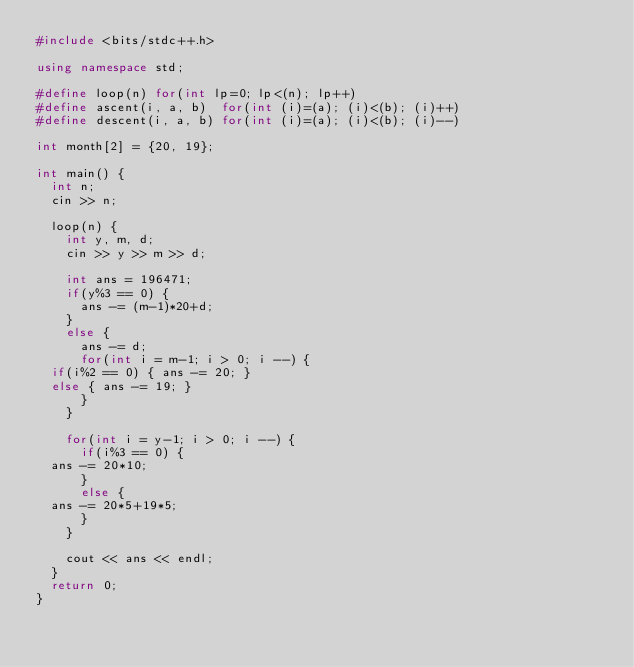Convert code to text. <code><loc_0><loc_0><loc_500><loc_500><_C++_>#include <bits/stdc++.h>

using namespace std;

#define loop(n) for(int lp=0; lp<(n); lp++)
#define ascent(i, a, b)  for(int (i)=(a); (i)<(b); (i)++)
#define descent(i, a, b) for(int (i)=(a); (i)<(b); (i)--)

int month[2] = {20, 19};

int main() {
  int n;
  cin >> n;

  loop(n) {
    int y, m, d;
    cin >> y >> m >> d;

    int ans = 196471;
    if(y%3 == 0) {
      ans -= (m-1)*20+d;
    }
    else {
      ans -= d;
      for(int i = m-1; i > 0; i --) {
	if(i%2 == 0) { ans -= 20; }
	else { ans -= 19; }
      }
    }

    for(int i = y-1; i > 0; i --) {
      if(i%3 == 0) {
	ans -= 20*10;
      }
      else {
	ans -= 20*5+19*5;
      }
    }

    cout << ans << endl;
  }
  return 0;
}</code> 